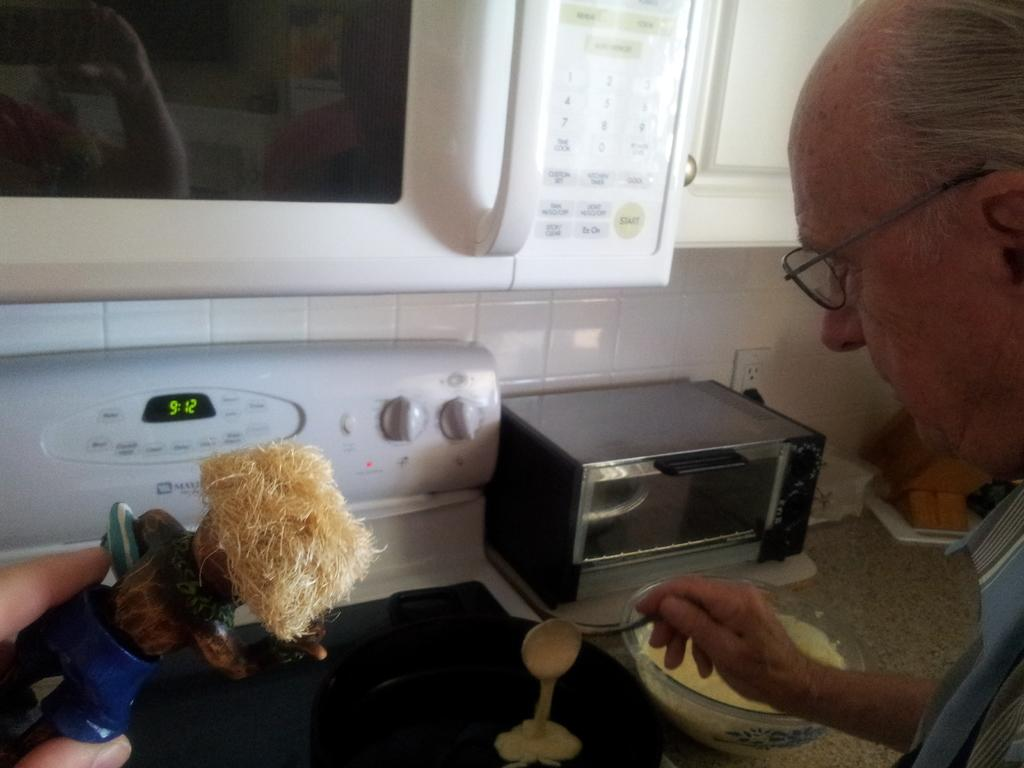<image>
Create a compact narrative representing the image presented. A man pouring pancake mix on the stove with the clock showing the time of 9:12. 